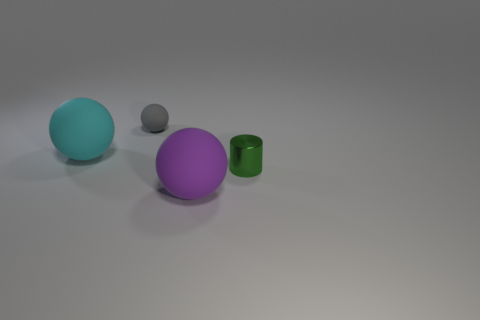Add 4 tiny green shiny things. How many objects exist? 8 Subtract 0 blue cylinders. How many objects are left? 4 Subtract all cylinders. How many objects are left? 3 Subtract all small rubber spheres. Subtract all large purple rubber things. How many objects are left? 2 Add 2 tiny things. How many tiny things are left? 4 Add 1 tiny blue shiny blocks. How many tiny blue shiny blocks exist? 1 